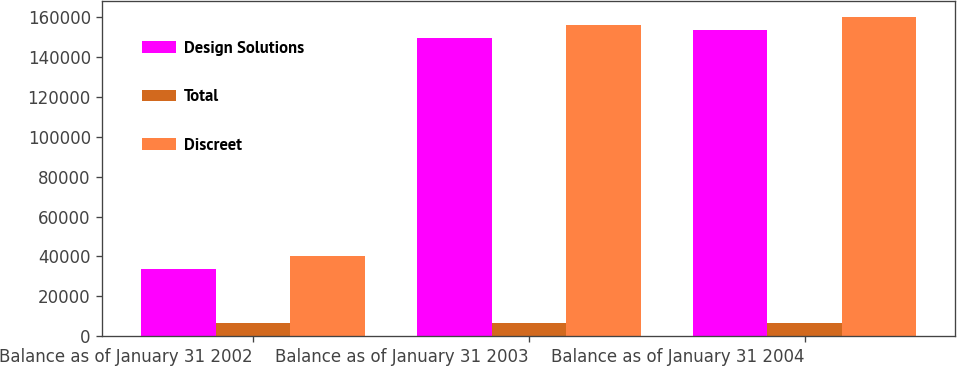Convert chart. <chart><loc_0><loc_0><loc_500><loc_500><stacked_bar_chart><ecel><fcel>Balance as of January 31 2002<fcel>Balance as of January 31 2003<fcel>Balance as of January 31 2004<nl><fcel>Design Solutions<fcel>33581<fcel>149539<fcel>153688<nl><fcel>Total<fcel>6406<fcel>6406<fcel>6406<nl><fcel>Discreet<fcel>39987<fcel>155945<fcel>160094<nl></chart> 